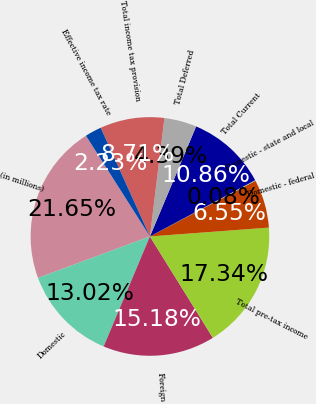Convert chart. <chart><loc_0><loc_0><loc_500><loc_500><pie_chart><fcel>(in millions)<fcel>Domestic<fcel>Foreign<fcel>Total pre-tax income<fcel>Domestic - federal<fcel>Domestic - state and local<fcel>Total Current<fcel>Total Deferred<fcel>Total income tax provision<fcel>Effective income tax rate<nl><fcel>21.65%<fcel>13.02%<fcel>15.18%<fcel>17.34%<fcel>6.55%<fcel>0.08%<fcel>10.86%<fcel>4.39%<fcel>8.71%<fcel>2.23%<nl></chart> 